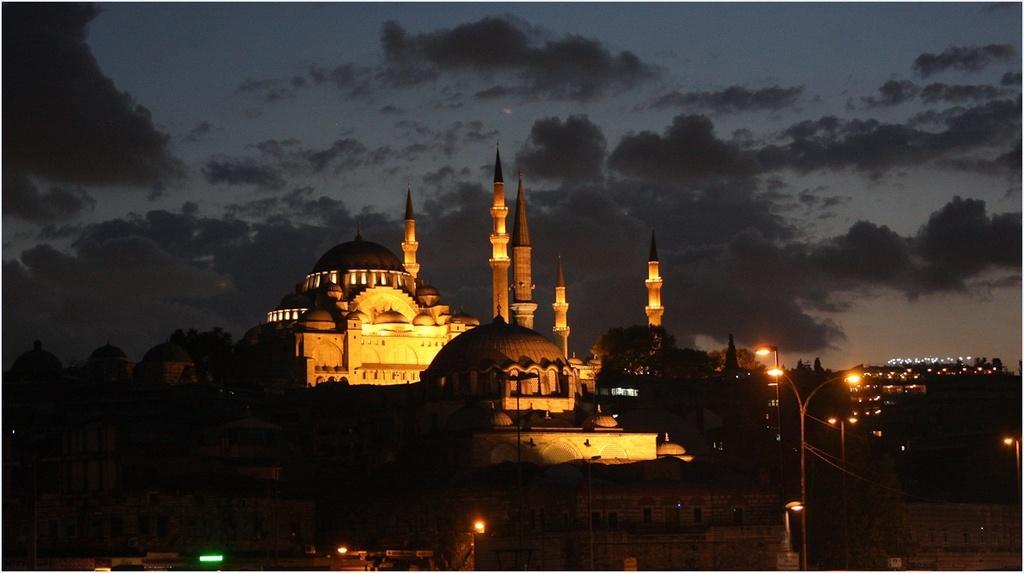Can you describe this image briefly? In the center of the image we can see a building with towers. To the right side of the image we can see light poles. In the background, we can see a group of trees and the cloudy sky. 